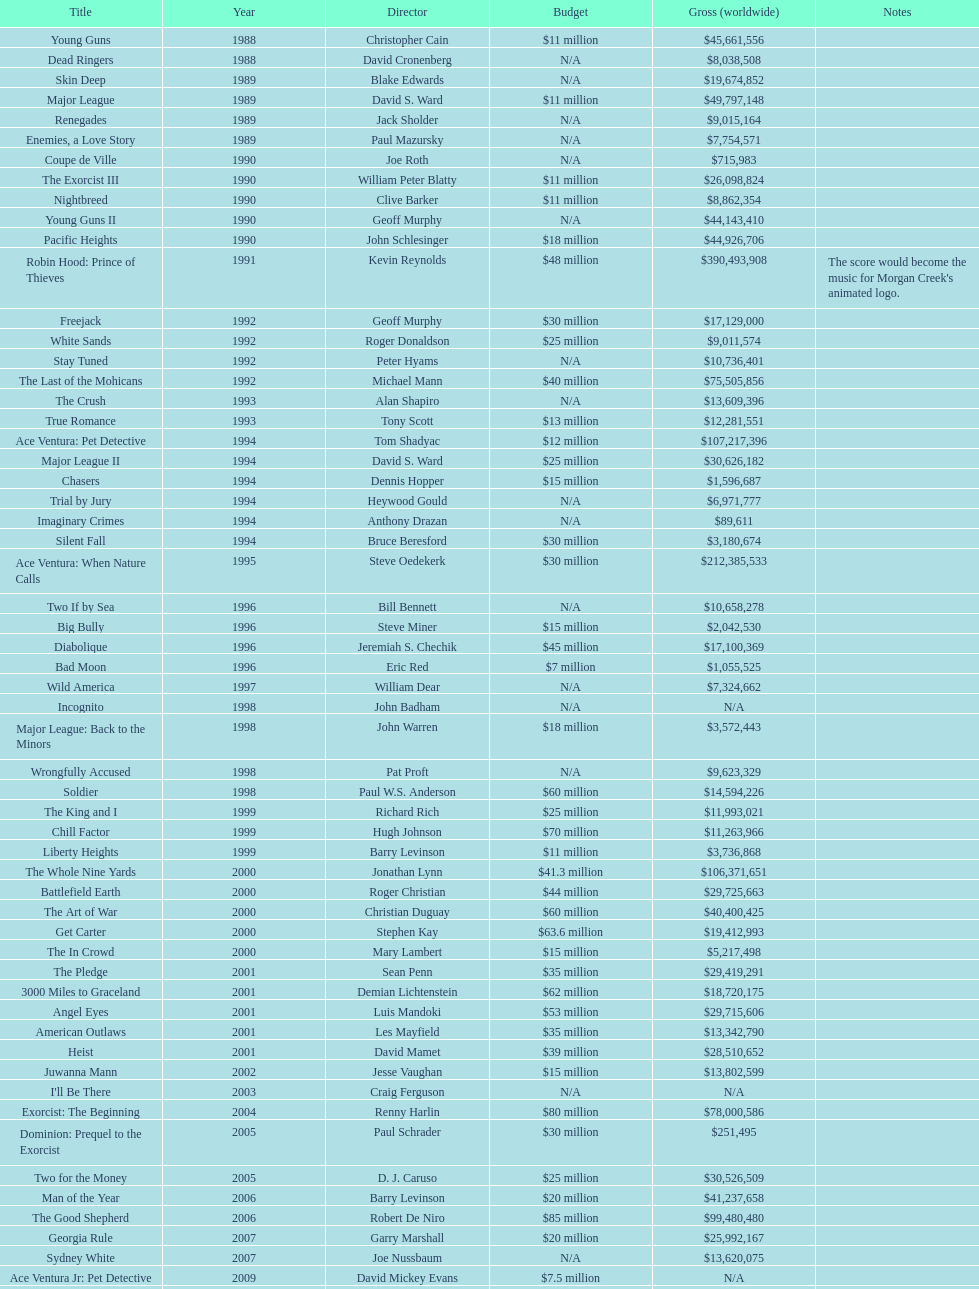Identify the only film with a budget set at 48 million dollars. Robin Hood: Prince of Thieves. 